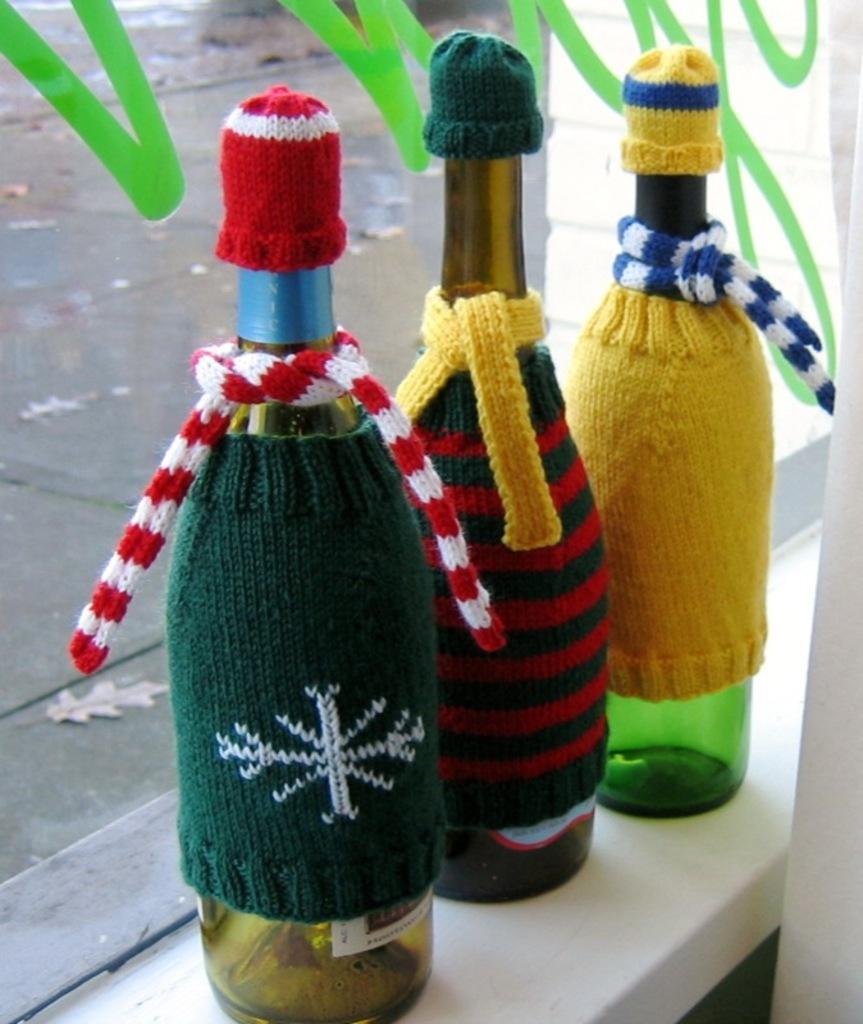Describe this image in one or two sentences. there are three bottles on table covered with wool on body and as a scarf and cap on them. 